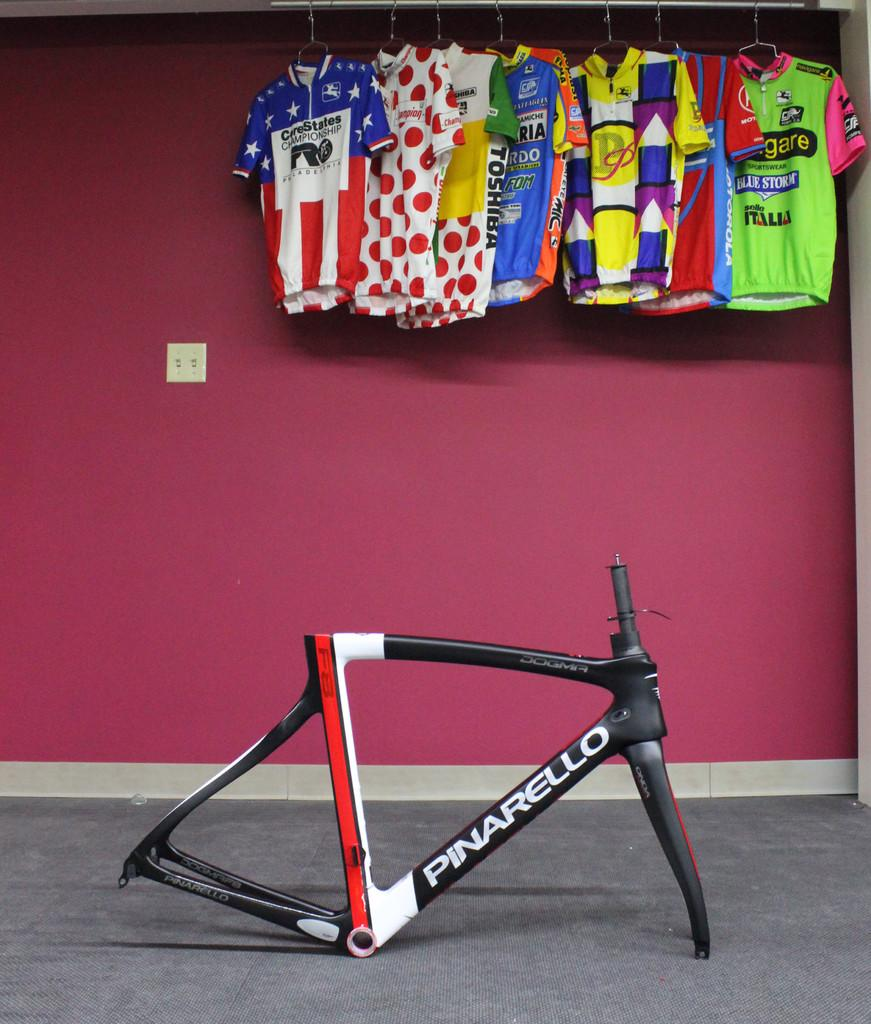Provide a one-sentence caption for the provided image. A Pinarello bike part sitting in front of a wall with hanging sports jerseys. 